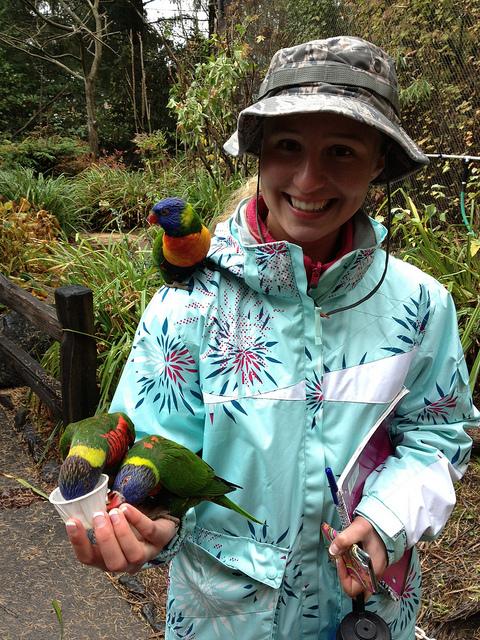Are those birds pets?
Give a very brief answer. Yes. What is the woman holding?
Give a very brief answer. Birds. What type of birds are these?
Keep it brief. Parrots. 